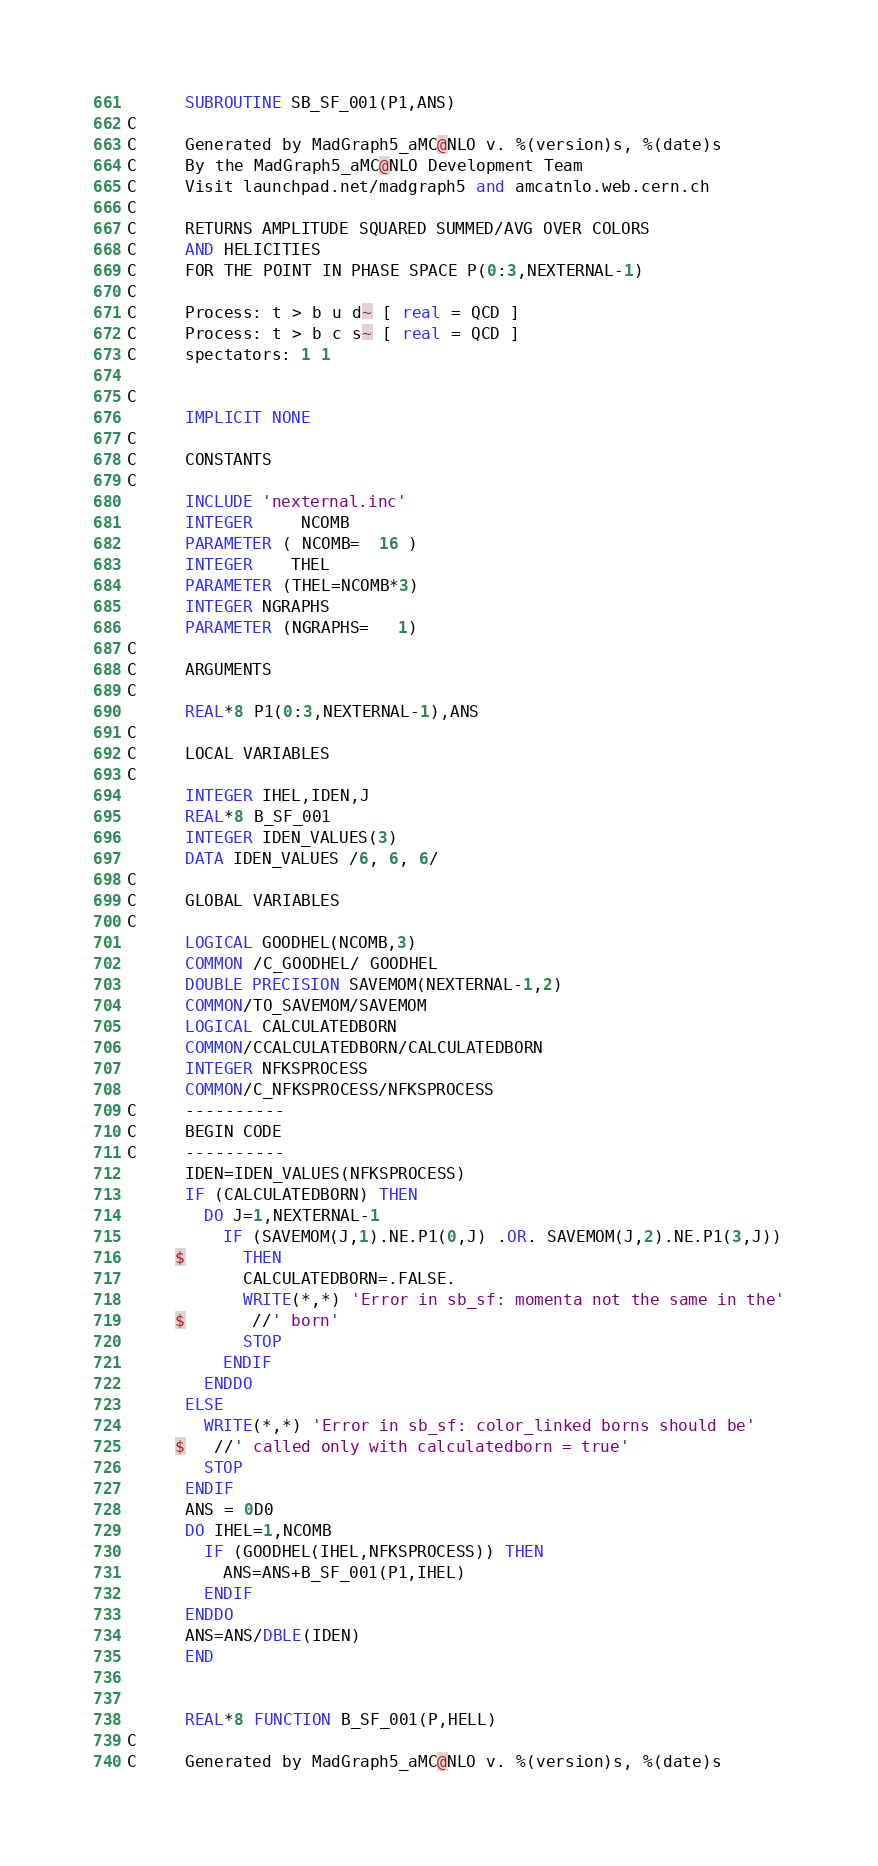<code> <loc_0><loc_0><loc_500><loc_500><_FORTRAN_>      SUBROUTINE SB_SF_001(P1,ANS)
C     
C     Generated by MadGraph5_aMC@NLO v. %(version)s, %(date)s
C     By the MadGraph5_aMC@NLO Development Team
C     Visit launchpad.net/madgraph5 and amcatnlo.web.cern.ch
C     
C     RETURNS AMPLITUDE SQUARED SUMMED/AVG OVER COLORS
C     AND HELICITIES
C     FOR THE POINT IN PHASE SPACE P(0:3,NEXTERNAL-1)
C     
C     Process: t > b u d~ [ real = QCD ]
C     Process: t > b c s~ [ real = QCD ]
C     spectators: 1 1 

C     
      IMPLICIT NONE
C     
C     CONSTANTS
C     
      INCLUDE 'nexternal.inc'
      INTEGER     NCOMB
      PARAMETER ( NCOMB=  16 )
      INTEGER    THEL
      PARAMETER (THEL=NCOMB*3)
      INTEGER NGRAPHS
      PARAMETER (NGRAPHS=   1)
C     
C     ARGUMENTS 
C     
      REAL*8 P1(0:3,NEXTERNAL-1),ANS
C     
C     LOCAL VARIABLES 
C     
      INTEGER IHEL,IDEN,J
      REAL*8 B_SF_001
      INTEGER IDEN_VALUES(3)
      DATA IDEN_VALUES /6, 6, 6/
C     
C     GLOBAL VARIABLES
C     
      LOGICAL GOODHEL(NCOMB,3)
      COMMON /C_GOODHEL/ GOODHEL
      DOUBLE PRECISION SAVEMOM(NEXTERNAL-1,2)
      COMMON/TO_SAVEMOM/SAVEMOM
      LOGICAL CALCULATEDBORN
      COMMON/CCALCULATEDBORN/CALCULATEDBORN
      INTEGER NFKSPROCESS
      COMMON/C_NFKSPROCESS/NFKSPROCESS
C     ----------
C     BEGIN CODE
C     ----------
      IDEN=IDEN_VALUES(NFKSPROCESS)
      IF (CALCULATEDBORN) THEN
        DO J=1,NEXTERNAL-1
          IF (SAVEMOM(J,1).NE.P1(0,J) .OR. SAVEMOM(J,2).NE.P1(3,J))
     $      THEN
            CALCULATEDBORN=.FALSE.
            WRITE(*,*) 'Error in sb_sf: momenta not the same in the'
     $       //' born'
            STOP
          ENDIF
        ENDDO
      ELSE
        WRITE(*,*) 'Error in sb_sf: color_linked borns should be'
     $   //' called only with calculatedborn = true'
        STOP
      ENDIF
      ANS = 0D0
      DO IHEL=1,NCOMB
        IF (GOODHEL(IHEL,NFKSPROCESS)) THEN
          ANS=ANS+B_SF_001(P1,IHEL)
        ENDIF
      ENDDO
      ANS=ANS/DBLE(IDEN)
      END


      REAL*8 FUNCTION B_SF_001(P,HELL)
C     
C     Generated by MadGraph5_aMC@NLO v. %(version)s, %(date)s</code> 